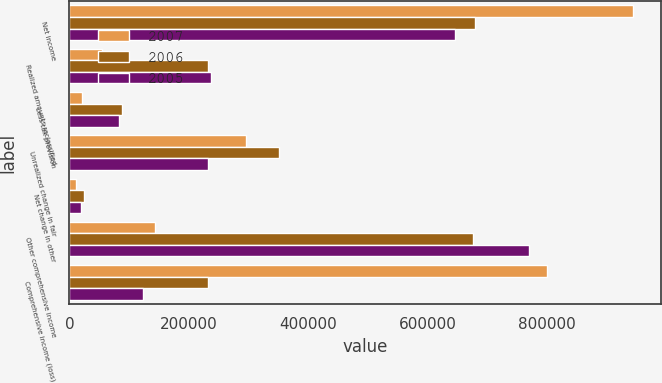Convert chart. <chart><loc_0><loc_0><loc_500><loc_500><stacked_bar_chart><ecel><fcel>Net income<fcel>Realized amounts reclassified<fcel>Less tax provision<fcel>Unrealized change in fair<fcel>Net change in other<fcel>Other comprehensive income<fcel>Comprehensive income (loss)<nl><fcel>2007<fcel>943870<fcel>54105<fcel>20344<fcel>295279<fcel>11369<fcel>143676<fcel>800194<nl><fcel>2006<fcel>678428<fcel>232428<fcel>87393<fcel>351637<fcel>25002<fcel>676391<fcel>232428<nl><fcel>2005<fcel>645720<fcel>237692<fcel>83192<fcel>232428<fcel>18937<fcel>768712<fcel>122992<nl></chart> 